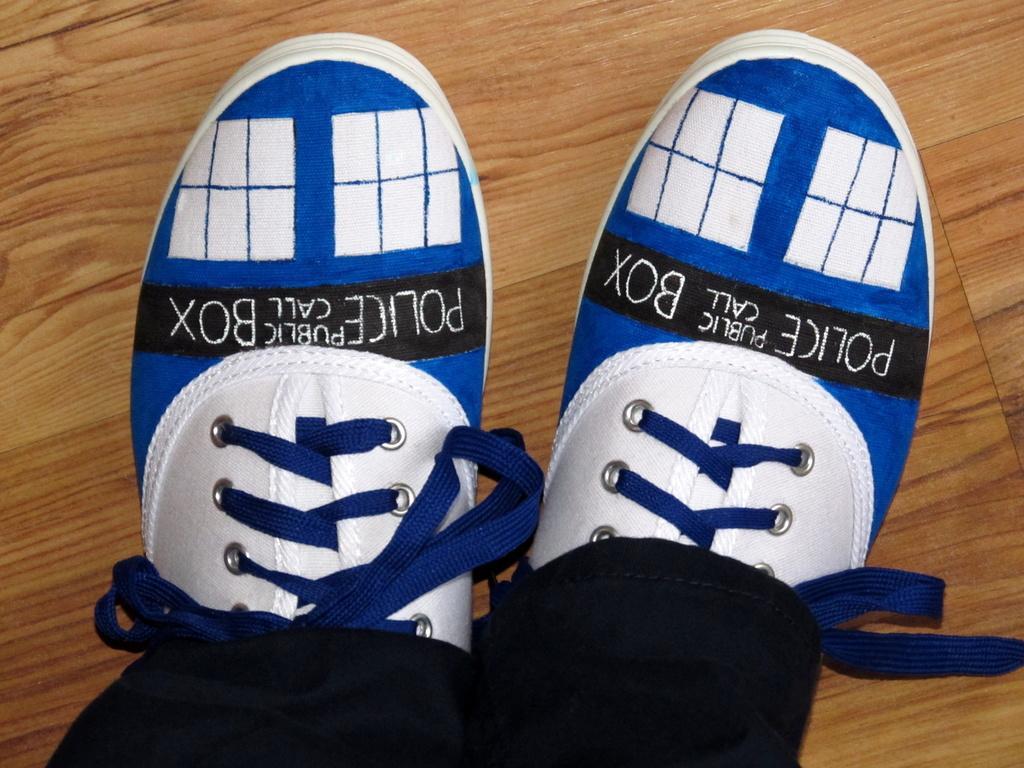Describe this image in one or two sentences. In this image we can see a person's legs with shoes on the wooden surface. 